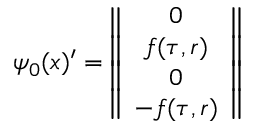Convert formula to latex. <formula><loc_0><loc_0><loc_500><loc_500>\psi _ { 0 } ( x ) ^ { \prime } = \left \| \begin{array} { c } { 0 } \\ { f ( \tau , r ) } \\ { 0 } \\ { - f ( \tau , r ) } \end{array} \right \|</formula> 